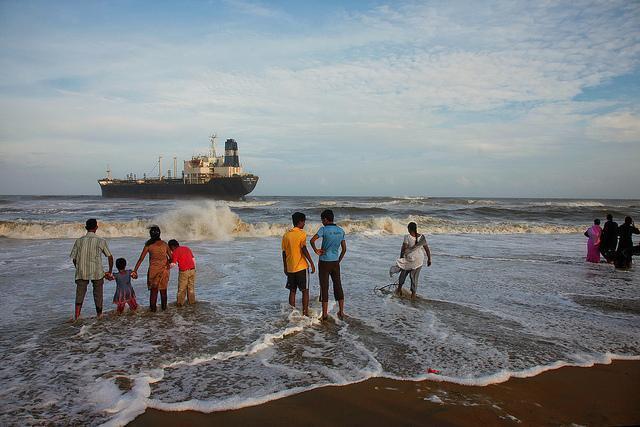How many people are visible?
Choose the right answer from the provided options to respond to the question.
Options: Five, 22, ten, 15. Ten. 